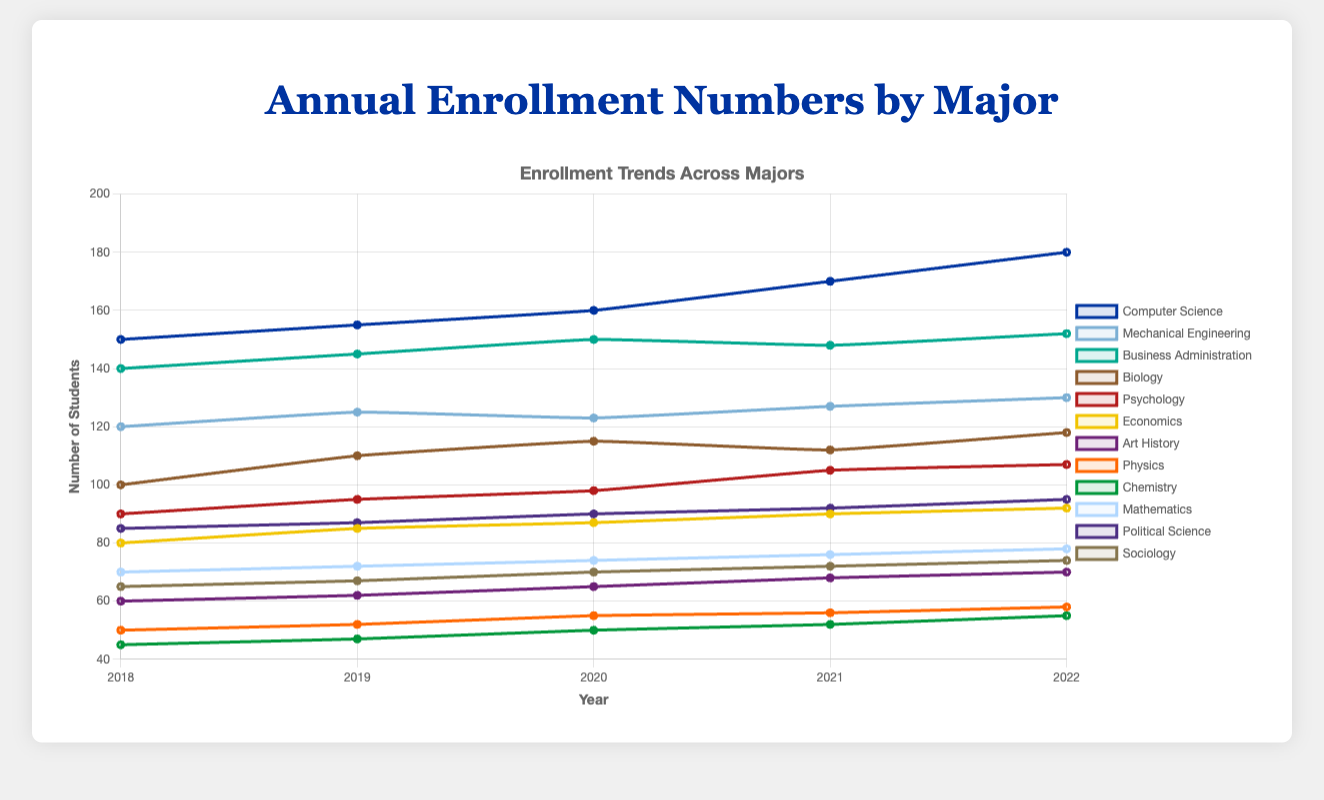Which major has the highest enrollment in 2022? By examining the line chart, the major with the highest data value at the year 2022 should be identified. In this case, Computer Science reaches 180.
Answer: Computer Science What is the total enrollment across all majors for the year 2020? Sum the data points of all majors for 2020: 160 (CS) + 123 (ME) + 150 (BA) + 115 (Bio) + 98 (Psych) + 87 (Econ) + 65 (AH) + 55 (Phys) + 50 (Chem) + 74 (Math) + 90 (PolSci) + 70 (Soc). The sum is 1137.
Answer: 1137 By how many students did the enrollment in Mechanical Engineering increase from 2018 to 2022? Subtract the enrollment in 2018 from that in 2022 for Mechanical Engineering: 130 (2022) - 120 (2018) = 10.
Answer: 10 Which major experienced the smallest increase in enrollment from 2018 to 2022? Calculate the increase for each major by subtracting the enrollment in 2018 from that in 2022. The smallest increase is found by comparing all the increments. The smallest is for Chemistry: 55 (2022) - 45 (2018) = 10.
Answer: Chemistry What is the average enrollment for Biology from 2018 to 2022? Add the enrollment numbers for Biology from 2018 to 2022 and divide by 5: (100 + 110 + 115 + 112 + 118) / 5 = 555 / 5 = 111.
Answer: 111 Which major has a consistently increasing trend every year from 2018 to 2022? Identify the major(s) where the enrollment number increases every subsequent year by checking each data point: Only Computer Science and Political Science increase every year.
Answer: Computer Science and Political Science How does the enrollment for Physics compare to that of Chemistry in 2020? Compare the values of 2020 for Physics and Chemistry. Physics has 55 and Chemistry has 50, so Physics has a higher enrollment.
Answer: Physics has higher enrollment What is the ratio of enrollment between Business Administration and Sociology in 2021? Divide the enrollment number of Business Administration by Sociology for 2021: 148 (BA) / 72 (Soc) = 2.06.
Answer: 2.06 Which majors have an enrollment of fewer than 70 students in 2019? Identify the majors with enrollment values less than 70 in 2019 by checking each: Economics (85), Art History (62), Physics (52), Chemistry (47), Mathematics (72), Sociology (67). The majors are Art History, Physics, and Chemistry.
Answer: Art History, Physics, Chemistry By how much did the enrollment for Psychology increase from 2019 to 2021? Subtract the 2019 enrollment value of Psychology from the 2021 value: 105 (2021) - 95 (2019) = 10.
Answer: 10 